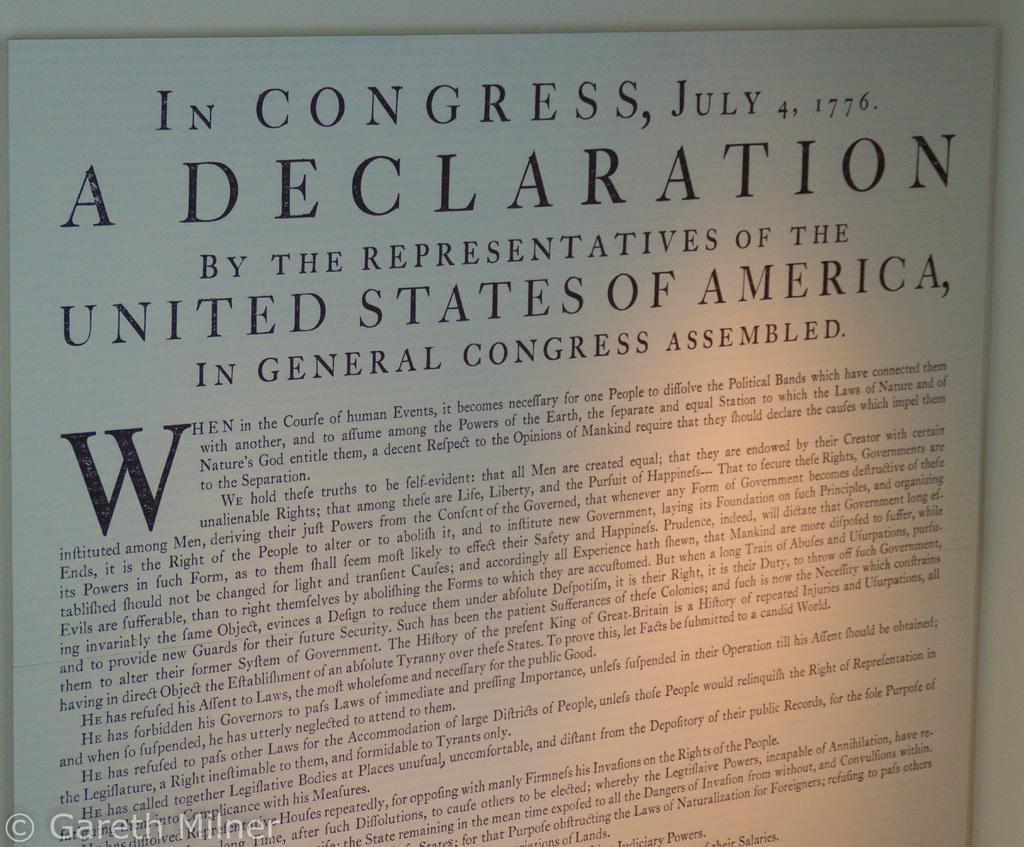<image>
Describe the image concisely. A congressional declaration from 1776 is shown in print. 